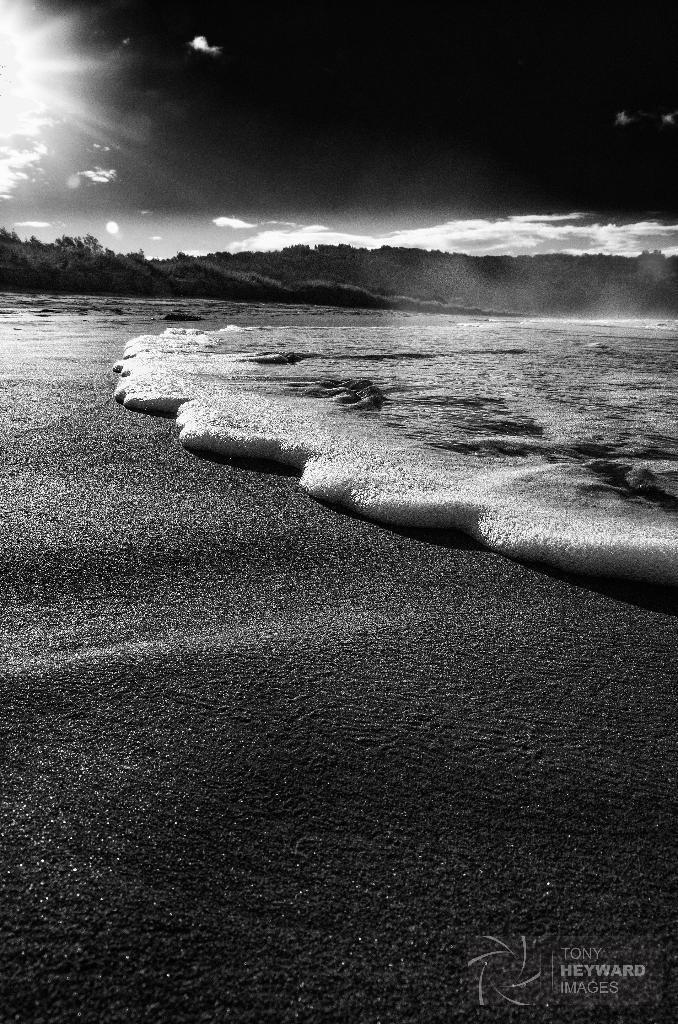Describe this image in one or two sentences. This is a black and white image. In this image we can see sky with clouds, trees and an ocean. 